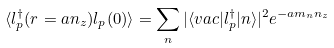Convert formula to latex. <formula><loc_0><loc_0><loc_500><loc_500>\langle l _ { p } ^ { \dagger } ( r = a n _ { z } ) l _ { p } ( 0 ) \rangle = \sum _ { n } | \langle v a c | l _ { p } ^ { \dagger } | n \rangle | ^ { 2 } e ^ { - a m _ { n } n _ { z } }</formula> 